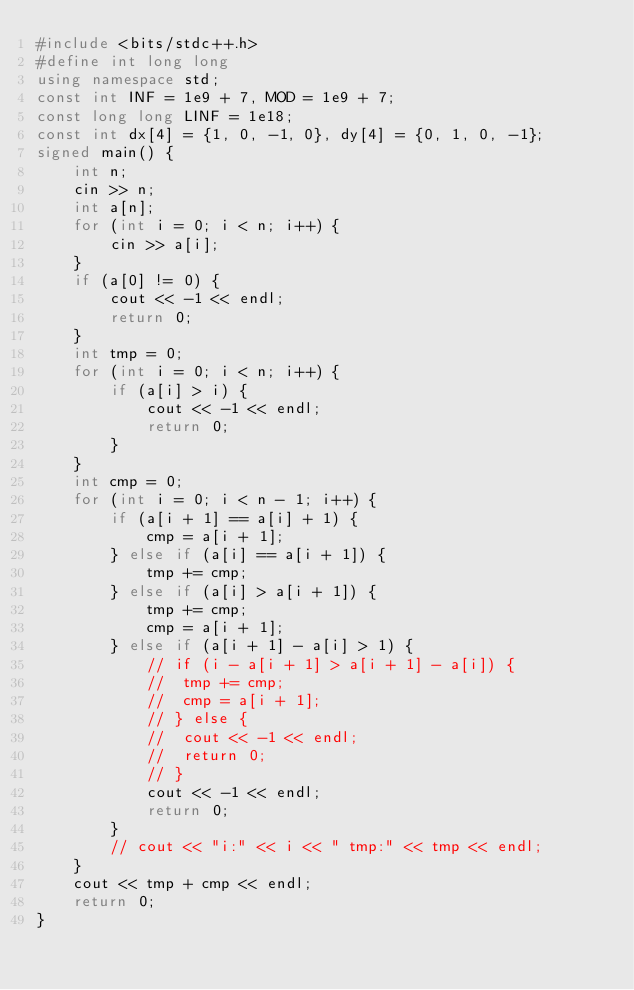<code> <loc_0><loc_0><loc_500><loc_500><_C++_>#include <bits/stdc++.h>
#define int long long
using namespace std;
const int INF = 1e9 + 7, MOD = 1e9 + 7;
const long long LINF = 1e18;
const int dx[4] = {1, 0, -1, 0}, dy[4] = {0, 1, 0, -1};
signed main() {
	int n;
	cin >> n;
	int a[n];
	for (int i = 0; i < n; i++) {
		cin >> a[i];
	}
	if (a[0] != 0) {
		cout << -1 << endl;
		return 0;
	}
	int tmp = 0;
	for (int i = 0; i < n; i++) {
		if (a[i] > i) {
			cout << -1 << endl;
			return 0;
		}
	}
	int cmp = 0;
	for (int i = 0; i < n - 1; i++) {
		if (a[i + 1] == a[i] + 1) {
			cmp = a[i + 1];
		} else if (a[i] == a[i + 1]) {
			tmp += cmp;
		} else if (a[i] > a[i + 1]) {
			tmp += cmp;
			cmp = a[i + 1];
		} else if (a[i + 1] - a[i] > 1) {
			// if (i - a[i + 1] > a[i + 1] - a[i]) {
			// 	tmp += cmp;
			// 	cmp = a[i + 1];
			// } else {
			// 	cout << -1 << endl;
			// 	return 0;
			// }
			cout << -1 << endl;
			return 0;
		}
		// cout << "i:" << i << " tmp:" << tmp << endl;
	}
	cout << tmp + cmp << endl;
	return 0;
}</code> 